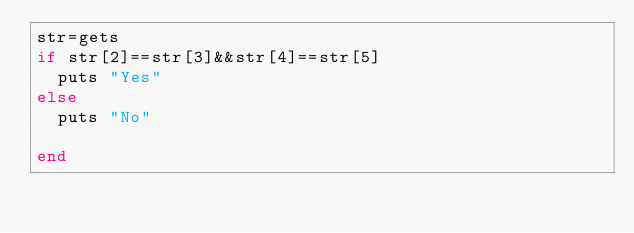Convert code to text. <code><loc_0><loc_0><loc_500><loc_500><_Ruby_>str=gets
if str[2]==str[3]&&str[4]==str[5]
  puts "Yes"
else
  puts "No"
  
end</code> 